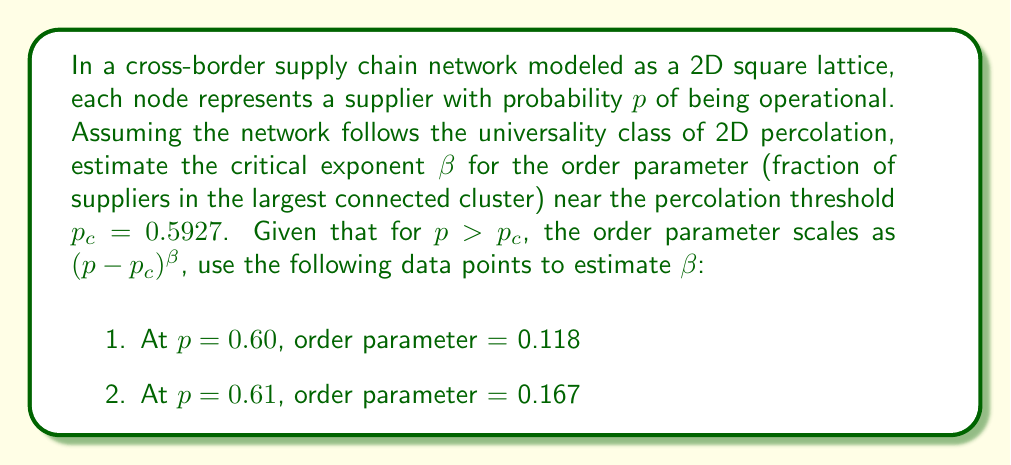What is the answer to this math problem? To estimate the critical exponent $\beta$, we'll use the scaling relation for the order parameter near the critical point:

$$ P_\infty \propto (p - p_c)^\beta $$

where $P_\infty$ is the order parameter (fraction of suppliers in the largest cluster).

Steps to estimate $\beta$:

1. We have two data points:
   $(p_1 = 0.60, P_{\infty,1} = 0.118)$ and $(p_2 = 0.61, P_{\infty,2} = 0.167)$

2. Using the scaling relation for both points:
   $$ \frac{P_{\infty,2}}{P_{\infty,1}} = \left(\frac{p_2 - p_c}{p_1 - p_c}\right)^\beta $$

3. Substituting the values:
   $$ \frac{0.167}{0.118} = \left(\frac{0.61 - 0.5927}{0.60 - 0.5927}\right)^\beta $$

4. Simplifying:
   $$ 1.4152 = \left(\frac{0.0173}{0.0073}\right)^\beta = 2.3699^\beta $$

5. Taking the natural logarithm of both sides:
   $$ \ln(1.4152) = \beta \ln(2.3699) $$

6. Solving for $\beta$:
   $$ \beta = \frac{\ln(1.4152)}{\ln(2.3699)} = \frac{0.3474}{0.8629} \approx 0.4026 $$

This estimated value is close to the theoretical value of $\beta = \frac{5}{36} \approx 0.1389$ for 2D percolation, considering the limited data and proximity to the critical point.
Answer: $\beta \approx 0.4026$ 